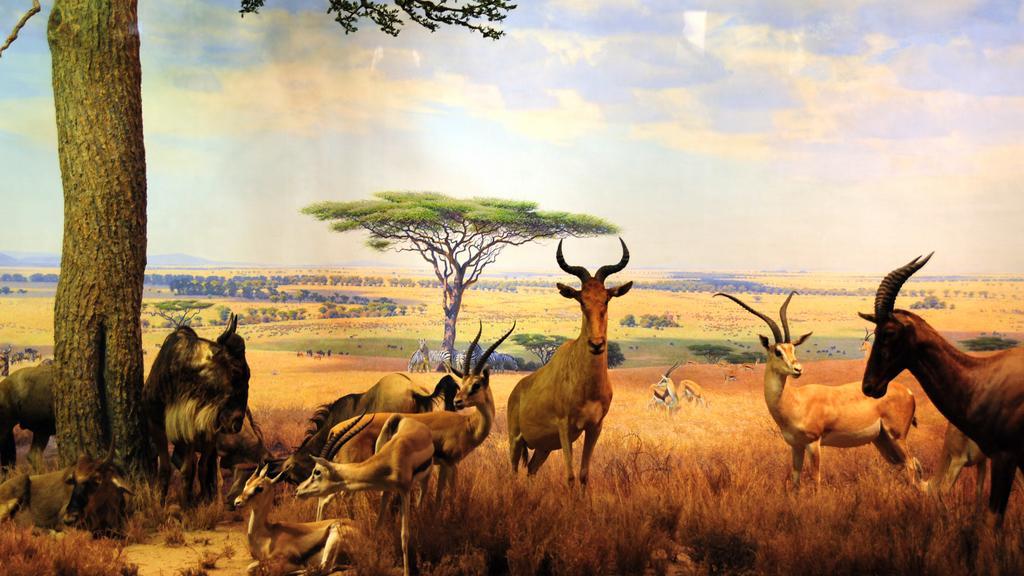Please provide a concise description of this image. This looks like an edited image. I can see different types of animals. This is the dried grass. I can see the trees. These are the clouds in the sky. 